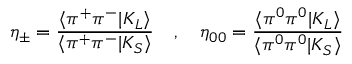<formula> <loc_0><loc_0><loc_500><loc_500>\eta _ { \pm } = \frac { \langle \pi ^ { + } \pi ^ { - } | K _ { L } \rangle } { \langle \pi ^ { + } \pi ^ { - } | K _ { S } \rangle } \quad , \quad \eta _ { 0 0 } = \frac { \langle \pi ^ { 0 } \pi ^ { 0 } | K _ { L } \rangle } { \langle \pi ^ { 0 } \pi ^ { 0 } | K _ { S } \rangle }</formula> 